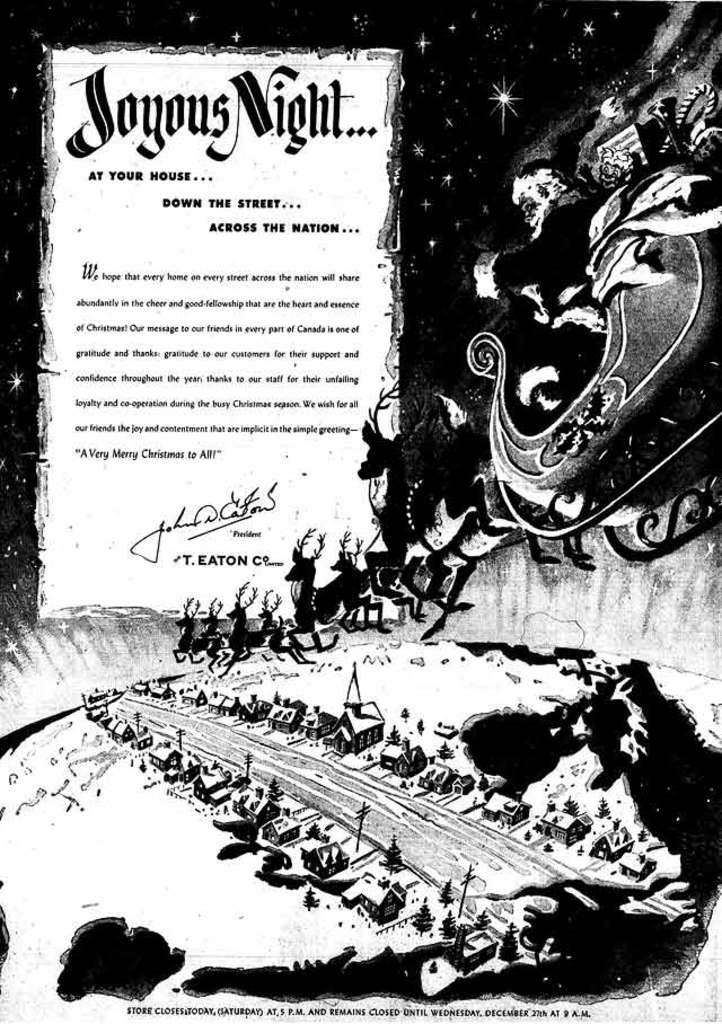Where is one place you can experience a joyous night?
Your answer should be very brief. At your house. 